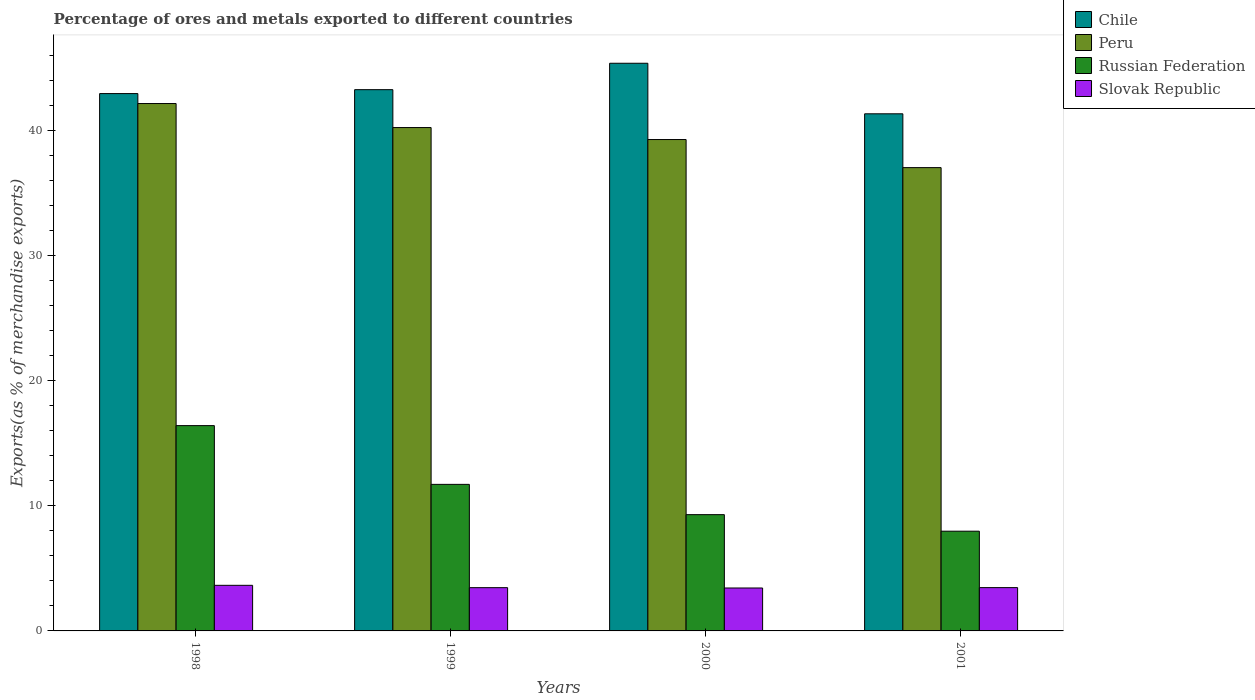Are the number of bars per tick equal to the number of legend labels?
Keep it short and to the point. Yes. Are the number of bars on each tick of the X-axis equal?
Make the answer very short. Yes. How many bars are there on the 1st tick from the left?
Give a very brief answer. 4. How many bars are there on the 3rd tick from the right?
Your answer should be very brief. 4. What is the label of the 4th group of bars from the left?
Your answer should be compact. 2001. In how many cases, is the number of bars for a given year not equal to the number of legend labels?
Give a very brief answer. 0. What is the percentage of exports to different countries in Russian Federation in 1998?
Your answer should be very brief. 16.4. Across all years, what is the maximum percentage of exports to different countries in Peru?
Make the answer very short. 42.13. Across all years, what is the minimum percentage of exports to different countries in Chile?
Offer a very short reply. 41.31. What is the total percentage of exports to different countries in Russian Federation in the graph?
Your response must be concise. 45.36. What is the difference between the percentage of exports to different countries in Russian Federation in 1998 and that in 1999?
Provide a short and direct response. 4.69. What is the difference between the percentage of exports to different countries in Russian Federation in 2000 and the percentage of exports to different countries in Slovak Republic in 1998?
Provide a short and direct response. 5.65. What is the average percentage of exports to different countries in Peru per year?
Offer a terse response. 39.65. In the year 2000, what is the difference between the percentage of exports to different countries in Russian Federation and percentage of exports to different countries in Chile?
Give a very brief answer. -36.06. In how many years, is the percentage of exports to different countries in Chile greater than 26 %?
Provide a short and direct response. 4. What is the ratio of the percentage of exports to different countries in Russian Federation in 1999 to that in 2000?
Provide a succinct answer. 1.26. Is the percentage of exports to different countries in Peru in 1999 less than that in 2001?
Ensure brevity in your answer.  No. Is the difference between the percentage of exports to different countries in Russian Federation in 1998 and 2001 greater than the difference between the percentage of exports to different countries in Chile in 1998 and 2001?
Your answer should be very brief. Yes. What is the difference between the highest and the second highest percentage of exports to different countries in Russian Federation?
Your answer should be compact. 4.69. What is the difference between the highest and the lowest percentage of exports to different countries in Slovak Republic?
Your response must be concise. 0.21. Is it the case that in every year, the sum of the percentage of exports to different countries in Russian Federation and percentage of exports to different countries in Chile is greater than the sum of percentage of exports to different countries in Peru and percentage of exports to different countries in Slovak Republic?
Give a very brief answer. No. What does the 3rd bar from the left in 2001 represents?
Give a very brief answer. Russian Federation. What does the 2nd bar from the right in 2000 represents?
Your response must be concise. Russian Federation. How many bars are there?
Give a very brief answer. 16. Are all the bars in the graph horizontal?
Offer a terse response. No. How many years are there in the graph?
Provide a succinct answer. 4. Are the values on the major ticks of Y-axis written in scientific E-notation?
Ensure brevity in your answer.  No. Does the graph contain any zero values?
Provide a short and direct response. No. Does the graph contain grids?
Provide a succinct answer. No. How many legend labels are there?
Offer a very short reply. 4. How are the legend labels stacked?
Keep it short and to the point. Vertical. What is the title of the graph?
Your response must be concise. Percentage of ores and metals exported to different countries. What is the label or title of the Y-axis?
Offer a very short reply. Exports(as % of merchandise exports). What is the Exports(as % of merchandise exports) in Chile in 1998?
Keep it short and to the point. 42.93. What is the Exports(as % of merchandise exports) of Peru in 1998?
Your answer should be compact. 42.13. What is the Exports(as % of merchandise exports) of Russian Federation in 1998?
Your answer should be compact. 16.4. What is the Exports(as % of merchandise exports) in Slovak Republic in 1998?
Provide a succinct answer. 3.64. What is the Exports(as % of merchandise exports) in Chile in 1999?
Keep it short and to the point. 43.24. What is the Exports(as % of merchandise exports) of Peru in 1999?
Provide a succinct answer. 40.21. What is the Exports(as % of merchandise exports) of Russian Federation in 1999?
Your answer should be compact. 11.71. What is the Exports(as % of merchandise exports) of Slovak Republic in 1999?
Offer a terse response. 3.46. What is the Exports(as % of merchandise exports) in Chile in 2000?
Provide a succinct answer. 45.35. What is the Exports(as % of merchandise exports) in Peru in 2000?
Your answer should be compact. 39.25. What is the Exports(as % of merchandise exports) in Russian Federation in 2000?
Provide a short and direct response. 9.29. What is the Exports(as % of merchandise exports) of Slovak Republic in 2000?
Provide a succinct answer. 3.43. What is the Exports(as % of merchandise exports) in Chile in 2001?
Your response must be concise. 41.31. What is the Exports(as % of merchandise exports) in Peru in 2001?
Make the answer very short. 37.01. What is the Exports(as % of merchandise exports) in Russian Federation in 2001?
Ensure brevity in your answer.  7.97. What is the Exports(as % of merchandise exports) of Slovak Republic in 2001?
Offer a very short reply. 3.46. Across all years, what is the maximum Exports(as % of merchandise exports) of Chile?
Your answer should be compact. 45.35. Across all years, what is the maximum Exports(as % of merchandise exports) in Peru?
Keep it short and to the point. 42.13. Across all years, what is the maximum Exports(as % of merchandise exports) of Russian Federation?
Offer a terse response. 16.4. Across all years, what is the maximum Exports(as % of merchandise exports) in Slovak Republic?
Keep it short and to the point. 3.64. Across all years, what is the minimum Exports(as % of merchandise exports) of Chile?
Give a very brief answer. 41.31. Across all years, what is the minimum Exports(as % of merchandise exports) in Peru?
Offer a very short reply. 37.01. Across all years, what is the minimum Exports(as % of merchandise exports) of Russian Federation?
Provide a short and direct response. 7.97. Across all years, what is the minimum Exports(as % of merchandise exports) of Slovak Republic?
Keep it short and to the point. 3.43. What is the total Exports(as % of merchandise exports) of Chile in the graph?
Your answer should be very brief. 172.82. What is the total Exports(as % of merchandise exports) in Peru in the graph?
Ensure brevity in your answer.  158.61. What is the total Exports(as % of merchandise exports) in Russian Federation in the graph?
Provide a succinct answer. 45.36. What is the total Exports(as % of merchandise exports) in Slovak Republic in the graph?
Your response must be concise. 13.99. What is the difference between the Exports(as % of merchandise exports) in Chile in 1998 and that in 1999?
Ensure brevity in your answer.  -0.31. What is the difference between the Exports(as % of merchandise exports) of Peru in 1998 and that in 1999?
Your answer should be very brief. 1.92. What is the difference between the Exports(as % of merchandise exports) of Russian Federation in 1998 and that in 1999?
Give a very brief answer. 4.69. What is the difference between the Exports(as % of merchandise exports) in Slovak Republic in 1998 and that in 1999?
Your response must be concise. 0.19. What is the difference between the Exports(as % of merchandise exports) of Chile in 1998 and that in 2000?
Your answer should be very brief. -2.42. What is the difference between the Exports(as % of merchandise exports) of Peru in 1998 and that in 2000?
Offer a very short reply. 2.88. What is the difference between the Exports(as % of merchandise exports) of Russian Federation in 1998 and that in 2000?
Keep it short and to the point. 7.11. What is the difference between the Exports(as % of merchandise exports) of Slovak Republic in 1998 and that in 2000?
Provide a short and direct response. 0.21. What is the difference between the Exports(as % of merchandise exports) of Chile in 1998 and that in 2001?
Your answer should be very brief. 1.61. What is the difference between the Exports(as % of merchandise exports) of Peru in 1998 and that in 2001?
Give a very brief answer. 5.12. What is the difference between the Exports(as % of merchandise exports) of Russian Federation in 1998 and that in 2001?
Give a very brief answer. 8.43. What is the difference between the Exports(as % of merchandise exports) in Slovak Republic in 1998 and that in 2001?
Your response must be concise. 0.18. What is the difference between the Exports(as % of merchandise exports) in Chile in 1999 and that in 2000?
Provide a short and direct response. -2.11. What is the difference between the Exports(as % of merchandise exports) in Peru in 1999 and that in 2000?
Your answer should be compact. 0.96. What is the difference between the Exports(as % of merchandise exports) in Russian Federation in 1999 and that in 2000?
Offer a very short reply. 2.42. What is the difference between the Exports(as % of merchandise exports) in Slovak Republic in 1999 and that in 2000?
Keep it short and to the point. 0.03. What is the difference between the Exports(as % of merchandise exports) of Chile in 1999 and that in 2001?
Your answer should be compact. 1.93. What is the difference between the Exports(as % of merchandise exports) of Peru in 1999 and that in 2001?
Your answer should be compact. 3.2. What is the difference between the Exports(as % of merchandise exports) in Russian Federation in 1999 and that in 2001?
Keep it short and to the point. 3.74. What is the difference between the Exports(as % of merchandise exports) of Slovak Republic in 1999 and that in 2001?
Offer a very short reply. -0. What is the difference between the Exports(as % of merchandise exports) in Chile in 2000 and that in 2001?
Offer a terse response. 4.04. What is the difference between the Exports(as % of merchandise exports) in Peru in 2000 and that in 2001?
Provide a short and direct response. 2.24. What is the difference between the Exports(as % of merchandise exports) of Russian Federation in 2000 and that in 2001?
Offer a very short reply. 1.32. What is the difference between the Exports(as % of merchandise exports) in Slovak Republic in 2000 and that in 2001?
Provide a succinct answer. -0.03. What is the difference between the Exports(as % of merchandise exports) of Chile in 1998 and the Exports(as % of merchandise exports) of Peru in 1999?
Offer a very short reply. 2.71. What is the difference between the Exports(as % of merchandise exports) of Chile in 1998 and the Exports(as % of merchandise exports) of Russian Federation in 1999?
Offer a very short reply. 31.22. What is the difference between the Exports(as % of merchandise exports) in Chile in 1998 and the Exports(as % of merchandise exports) in Slovak Republic in 1999?
Offer a terse response. 39.47. What is the difference between the Exports(as % of merchandise exports) of Peru in 1998 and the Exports(as % of merchandise exports) of Russian Federation in 1999?
Provide a short and direct response. 30.42. What is the difference between the Exports(as % of merchandise exports) in Peru in 1998 and the Exports(as % of merchandise exports) in Slovak Republic in 1999?
Provide a succinct answer. 38.68. What is the difference between the Exports(as % of merchandise exports) in Russian Federation in 1998 and the Exports(as % of merchandise exports) in Slovak Republic in 1999?
Offer a very short reply. 12.95. What is the difference between the Exports(as % of merchandise exports) in Chile in 1998 and the Exports(as % of merchandise exports) in Peru in 2000?
Give a very brief answer. 3.67. What is the difference between the Exports(as % of merchandise exports) in Chile in 1998 and the Exports(as % of merchandise exports) in Russian Federation in 2000?
Offer a very short reply. 33.64. What is the difference between the Exports(as % of merchandise exports) of Chile in 1998 and the Exports(as % of merchandise exports) of Slovak Republic in 2000?
Provide a succinct answer. 39.5. What is the difference between the Exports(as % of merchandise exports) of Peru in 1998 and the Exports(as % of merchandise exports) of Russian Federation in 2000?
Keep it short and to the point. 32.84. What is the difference between the Exports(as % of merchandise exports) in Peru in 1998 and the Exports(as % of merchandise exports) in Slovak Republic in 2000?
Provide a succinct answer. 38.7. What is the difference between the Exports(as % of merchandise exports) of Russian Federation in 1998 and the Exports(as % of merchandise exports) of Slovak Republic in 2000?
Make the answer very short. 12.97. What is the difference between the Exports(as % of merchandise exports) in Chile in 1998 and the Exports(as % of merchandise exports) in Peru in 2001?
Keep it short and to the point. 5.91. What is the difference between the Exports(as % of merchandise exports) in Chile in 1998 and the Exports(as % of merchandise exports) in Russian Federation in 2001?
Your answer should be very brief. 34.96. What is the difference between the Exports(as % of merchandise exports) of Chile in 1998 and the Exports(as % of merchandise exports) of Slovak Republic in 2001?
Make the answer very short. 39.47. What is the difference between the Exports(as % of merchandise exports) in Peru in 1998 and the Exports(as % of merchandise exports) in Russian Federation in 2001?
Your response must be concise. 34.16. What is the difference between the Exports(as % of merchandise exports) of Peru in 1998 and the Exports(as % of merchandise exports) of Slovak Republic in 2001?
Provide a short and direct response. 38.67. What is the difference between the Exports(as % of merchandise exports) of Russian Federation in 1998 and the Exports(as % of merchandise exports) of Slovak Republic in 2001?
Your answer should be very brief. 12.94. What is the difference between the Exports(as % of merchandise exports) in Chile in 1999 and the Exports(as % of merchandise exports) in Peru in 2000?
Your answer should be compact. 3.98. What is the difference between the Exports(as % of merchandise exports) in Chile in 1999 and the Exports(as % of merchandise exports) in Russian Federation in 2000?
Your answer should be compact. 33.95. What is the difference between the Exports(as % of merchandise exports) of Chile in 1999 and the Exports(as % of merchandise exports) of Slovak Republic in 2000?
Offer a very short reply. 39.81. What is the difference between the Exports(as % of merchandise exports) of Peru in 1999 and the Exports(as % of merchandise exports) of Russian Federation in 2000?
Keep it short and to the point. 30.92. What is the difference between the Exports(as % of merchandise exports) of Peru in 1999 and the Exports(as % of merchandise exports) of Slovak Republic in 2000?
Your answer should be compact. 36.78. What is the difference between the Exports(as % of merchandise exports) of Russian Federation in 1999 and the Exports(as % of merchandise exports) of Slovak Republic in 2000?
Your answer should be very brief. 8.28. What is the difference between the Exports(as % of merchandise exports) of Chile in 1999 and the Exports(as % of merchandise exports) of Peru in 2001?
Ensure brevity in your answer.  6.23. What is the difference between the Exports(as % of merchandise exports) of Chile in 1999 and the Exports(as % of merchandise exports) of Russian Federation in 2001?
Offer a very short reply. 35.27. What is the difference between the Exports(as % of merchandise exports) in Chile in 1999 and the Exports(as % of merchandise exports) in Slovak Republic in 2001?
Keep it short and to the point. 39.78. What is the difference between the Exports(as % of merchandise exports) of Peru in 1999 and the Exports(as % of merchandise exports) of Russian Federation in 2001?
Offer a very short reply. 32.25. What is the difference between the Exports(as % of merchandise exports) of Peru in 1999 and the Exports(as % of merchandise exports) of Slovak Republic in 2001?
Offer a terse response. 36.75. What is the difference between the Exports(as % of merchandise exports) in Russian Federation in 1999 and the Exports(as % of merchandise exports) in Slovak Republic in 2001?
Give a very brief answer. 8.25. What is the difference between the Exports(as % of merchandise exports) in Chile in 2000 and the Exports(as % of merchandise exports) in Peru in 2001?
Make the answer very short. 8.34. What is the difference between the Exports(as % of merchandise exports) in Chile in 2000 and the Exports(as % of merchandise exports) in Russian Federation in 2001?
Ensure brevity in your answer.  37.38. What is the difference between the Exports(as % of merchandise exports) in Chile in 2000 and the Exports(as % of merchandise exports) in Slovak Republic in 2001?
Make the answer very short. 41.89. What is the difference between the Exports(as % of merchandise exports) in Peru in 2000 and the Exports(as % of merchandise exports) in Russian Federation in 2001?
Give a very brief answer. 31.29. What is the difference between the Exports(as % of merchandise exports) in Peru in 2000 and the Exports(as % of merchandise exports) in Slovak Republic in 2001?
Keep it short and to the point. 35.79. What is the difference between the Exports(as % of merchandise exports) in Russian Federation in 2000 and the Exports(as % of merchandise exports) in Slovak Republic in 2001?
Offer a terse response. 5.83. What is the average Exports(as % of merchandise exports) in Chile per year?
Your answer should be very brief. 43.21. What is the average Exports(as % of merchandise exports) of Peru per year?
Make the answer very short. 39.65. What is the average Exports(as % of merchandise exports) of Russian Federation per year?
Provide a short and direct response. 11.34. What is the average Exports(as % of merchandise exports) of Slovak Republic per year?
Provide a succinct answer. 3.5. In the year 1998, what is the difference between the Exports(as % of merchandise exports) of Chile and Exports(as % of merchandise exports) of Peru?
Provide a succinct answer. 0.79. In the year 1998, what is the difference between the Exports(as % of merchandise exports) in Chile and Exports(as % of merchandise exports) in Russian Federation?
Offer a terse response. 26.52. In the year 1998, what is the difference between the Exports(as % of merchandise exports) of Chile and Exports(as % of merchandise exports) of Slovak Republic?
Provide a short and direct response. 39.28. In the year 1998, what is the difference between the Exports(as % of merchandise exports) in Peru and Exports(as % of merchandise exports) in Russian Federation?
Your answer should be compact. 25.73. In the year 1998, what is the difference between the Exports(as % of merchandise exports) of Peru and Exports(as % of merchandise exports) of Slovak Republic?
Offer a terse response. 38.49. In the year 1998, what is the difference between the Exports(as % of merchandise exports) in Russian Federation and Exports(as % of merchandise exports) in Slovak Republic?
Provide a succinct answer. 12.76. In the year 1999, what is the difference between the Exports(as % of merchandise exports) in Chile and Exports(as % of merchandise exports) in Peru?
Offer a terse response. 3.03. In the year 1999, what is the difference between the Exports(as % of merchandise exports) of Chile and Exports(as % of merchandise exports) of Russian Federation?
Offer a very short reply. 31.53. In the year 1999, what is the difference between the Exports(as % of merchandise exports) of Chile and Exports(as % of merchandise exports) of Slovak Republic?
Offer a terse response. 39.78. In the year 1999, what is the difference between the Exports(as % of merchandise exports) of Peru and Exports(as % of merchandise exports) of Russian Federation?
Ensure brevity in your answer.  28.5. In the year 1999, what is the difference between the Exports(as % of merchandise exports) of Peru and Exports(as % of merchandise exports) of Slovak Republic?
Offer a terse response. 36.76. In the year 1999, what is the difference between the Exports(as % of merchandise exports) in Russian Federation and Exports(as % of merchandise exports) in Slovak Republic?
Give a very brief answer. 8.25. In the year 2000, what is the difference between the Exports(as % of merchandise exports) in Chile and Exports(as % of merchandise exports) in Peru?
Make the answer very short. 6.09. In the year 2000, what is the difference between the Exports(as % of merchandise exports) of Chile and Exports(as % of merchandise exports) of Russian Federation?
Make the answer very short. 36.06. In the year 2000, what is the difference between the Exports(as % of merchandise exports) in Chile and Exports(as % of merchandise exports) in Slovak Republic?
Your answer should be very brief. 41.92. In the year 2000, what is the difference between the Exports(as % of merchandise exports) of Peru and Exports(as % of merchandise exports) of Russian Federation?
Your response must be concise. 29.97. In the year 2000, what is the difference between the Exports(as % of merchandise exports) of Peru and Exports(as % of merchandise exports) of Slovak Republic?
Your response must be concise. 35.82. In the year 2000, what is the difference between the Exports(as % of merchandise exports) of Russian Federation and Exports(as % of merchandise exports) of Slovak Republic?
Keep it short and to the point. 5.86. In the year 2001, what is the difference between the Exports(as % of merchandise exports) of Chile and Exports(as % of merchandise exports) of Peru?
Keep it short and to the point. 4.3. In the year 2001, what is the difference between the Exports(as % of merchandise exports) in Chile and Exports(as % of merchandise exports) in Russian Federation?
Keep it short and to the point. 33.34. In the year 2001, what is the difference between the Exports(as % of merchandise exports) in Chile and Exports(as % of merchandise exports) in Slovak Republic?
Make the answer very short. 37.85. In the year 2001, what is the difference between the Exports(as % of merchandise exports) in Peru and Exports(as % of merchandise exports) in Russian Federation?
Your answer should be very brief. 29.04. In the year 2001, what is the difference between the Exports(as % of merchandise exports) in Peru and Exports(as % of merchandise exports) in Slovak Republic?
Make the answer very short. 33.55. In the year 2001, what is the difference between the Exports(as % of merchandise exports) in Russian Federation and Exports(as % of merchandise exports) in Slovak Republic?
Your answer should be very brief. 4.51. What is the ratio of the Exports(as % of merchandise exports) in Peru in 1998 to that in 1999?
Offer a terse response. 1.05. What is the ratio of the Exports(as % of merchandise exports) in Russian Federation in 1998 to that in 1999?
Keep it short and to the point. 1.4. What is the ratio of the Exports(as % of merchandise exports) of Slovak Republic in 1998 to that in 1999?
Provide a succinct answer. 1.05. What is the ratio of the Exports(as % of merchandise exports) of Chile in 1998 to that in 2000?
Keep it short and to the point. 0.95. What is the ratio of the Exports(as % of merchandise exports) of Peru in 1998 to that in 2000?
Give a very brief answer. 1.07. What is the ratio of the Exports(as % of merchandise exports) in Russian Federation in 1998 to that in 2000?
Your response must be concise. 1.77. What is the ratio of the Exports(as % of merchandise exports) in Slovak Republic in 1998 to that in 2000?
Offer a very short reply. 1.06. What is the ratio of the Exports(as % of merchandise exports) in Chile in 1998 to that in 2001?
Ensure brevity in your answer.  1.04. What is the ratio of the Exports(as % of merchandise exports) in Peru in 1998 to that in 2001?
Your answer should be very brief. 1.14. What is the ratio of the Exports(as % of merchandise exports) of Russian Federation in 1998 to that in 2001?
Your response must be concise. 2.06. What is the ratio of the Exports(as % of merchandise exports) in Slovak Republic in 1998 to that in 2001?
Give a very brief answer. 1.05. What is the ratio of the Exports(as % of merchandise exports) in Chile in 1999 to that in 2000?
Your response must be concise. 0.95. What is the ratio of the Exports(as % of merchandise exports) of Peru in 1999 to that in 2000?
Offer a very short reply. 1.02. What is the ratio of the Exports(as % of merchandise exports) of Russian Federation in 1999 to that in 2000?
Keep it short and to the point. 1.26. What is the ratio of the Exports(as % of merchandise exports) in Slovak Republic in 1999 to that in 2000?
Give a very brief answer. 1.01. What is the ratio of the Exports(as % of merchandise exports) in Chile in 1999 to that in 2001?
Your answer should be compact. 1.05. What is the ratio of the Exports(as % of merchandise exports) in Peru in 1999 to that in 2001?
Your answer should be very brief. 1.09. What is the ratio of the Exports(as % of merchandise exports) in Russian Federation in 1999 to that in 2001?
Make the answer very short. 1.47. What is the ratio of the Exports(as % of merchandise exports) of Chile in 2000 to that in 2001?
Give a very brief answer. 1.1. What is the ratio of the Exports(as % of merchandise exports) of Peru in 2000 to that in 2001?
Offer a terse response. 1.06. What is the ratio of the Exports(as % of merchandise exports) of Russian Federation in 2000 to that in 2001?
Ensure brevity in your answer.  1.17. What is the difference between the highest and the second highest Exports(as % of merchandise exports) in Chile?
Your response must be concise. 2.11. What is the difference between the highest and the second highest Exports(as % of merchandise exports) of Peru?
Offer a very short reply. 1.92. What is the difference between the highest and the second highest Exports(as % of merchandise exports) in Russian Federation?
Your answer should be very brief. 4.69. What is the difference between the highest and the second highest Exports(as % of merchandise exports) in Slovak Republic?
Provide a succinct answer. 0.18. What is the difference between the highest and the lowest Exports(as % of merchandise exports) in Chile?
Offer a terse response. 4.04. What is the difference between the highest and the lowest Exports(as % of merchandise exports) in Peru?
Your answer should be compact. 5.12. What is the difference between the highest and the lowest Exports(as % of merchandise exports) of Russian Federation?
Your answer should be compact. 8.43. What is the difference between the highest and the lowest Exports(as % of merchandise exports) in Slovak Republic?
Offer a very short reply. 0.21. 